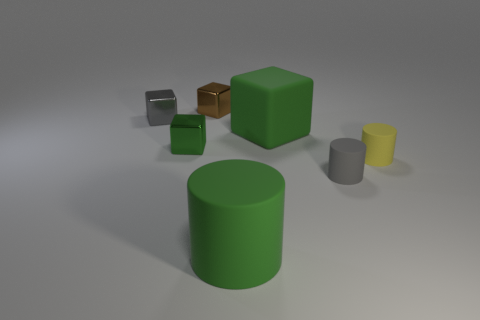Are there more tiny gray rubber cylinders than things?
Provide a succinct answer. No. There is a yellow cylinder that is the same material as the big green cube; what is its size?
Offer a very short reply. Small. There is a matte object behind the yellow matte object; does it have the same size as the gray thing that is behind the tiny yellow cylinder?
Ensure brevity in your answer.  No. How many things are either tiny metallic blocks on the right side of the tiny gray metal thing or green cubes?
Offer a terse response. 3. Are there fewer small metallic things than gray cylinders?
Provide a succinct answer. No. The tiny object that is behind the gray object that is behind the tiny metal object that is in front of the matte cube is what shape?
Your response must be concise. Cube. There is a small metallic thing that is the same color as the large cube; what shape is it?
Ensure brevity in your answer.  Cube. Is there a purple rubber cube?
Provide a short and direct response. No. There is a green matte cylinder; is it the same size as the shiny block behind the small gray shiny block?
Offer a terse response. No. There is a large green thing that is in front of the tiny yellow cylinder; are there any big things that are on the left side of it?
Offer a very short reply. No. 